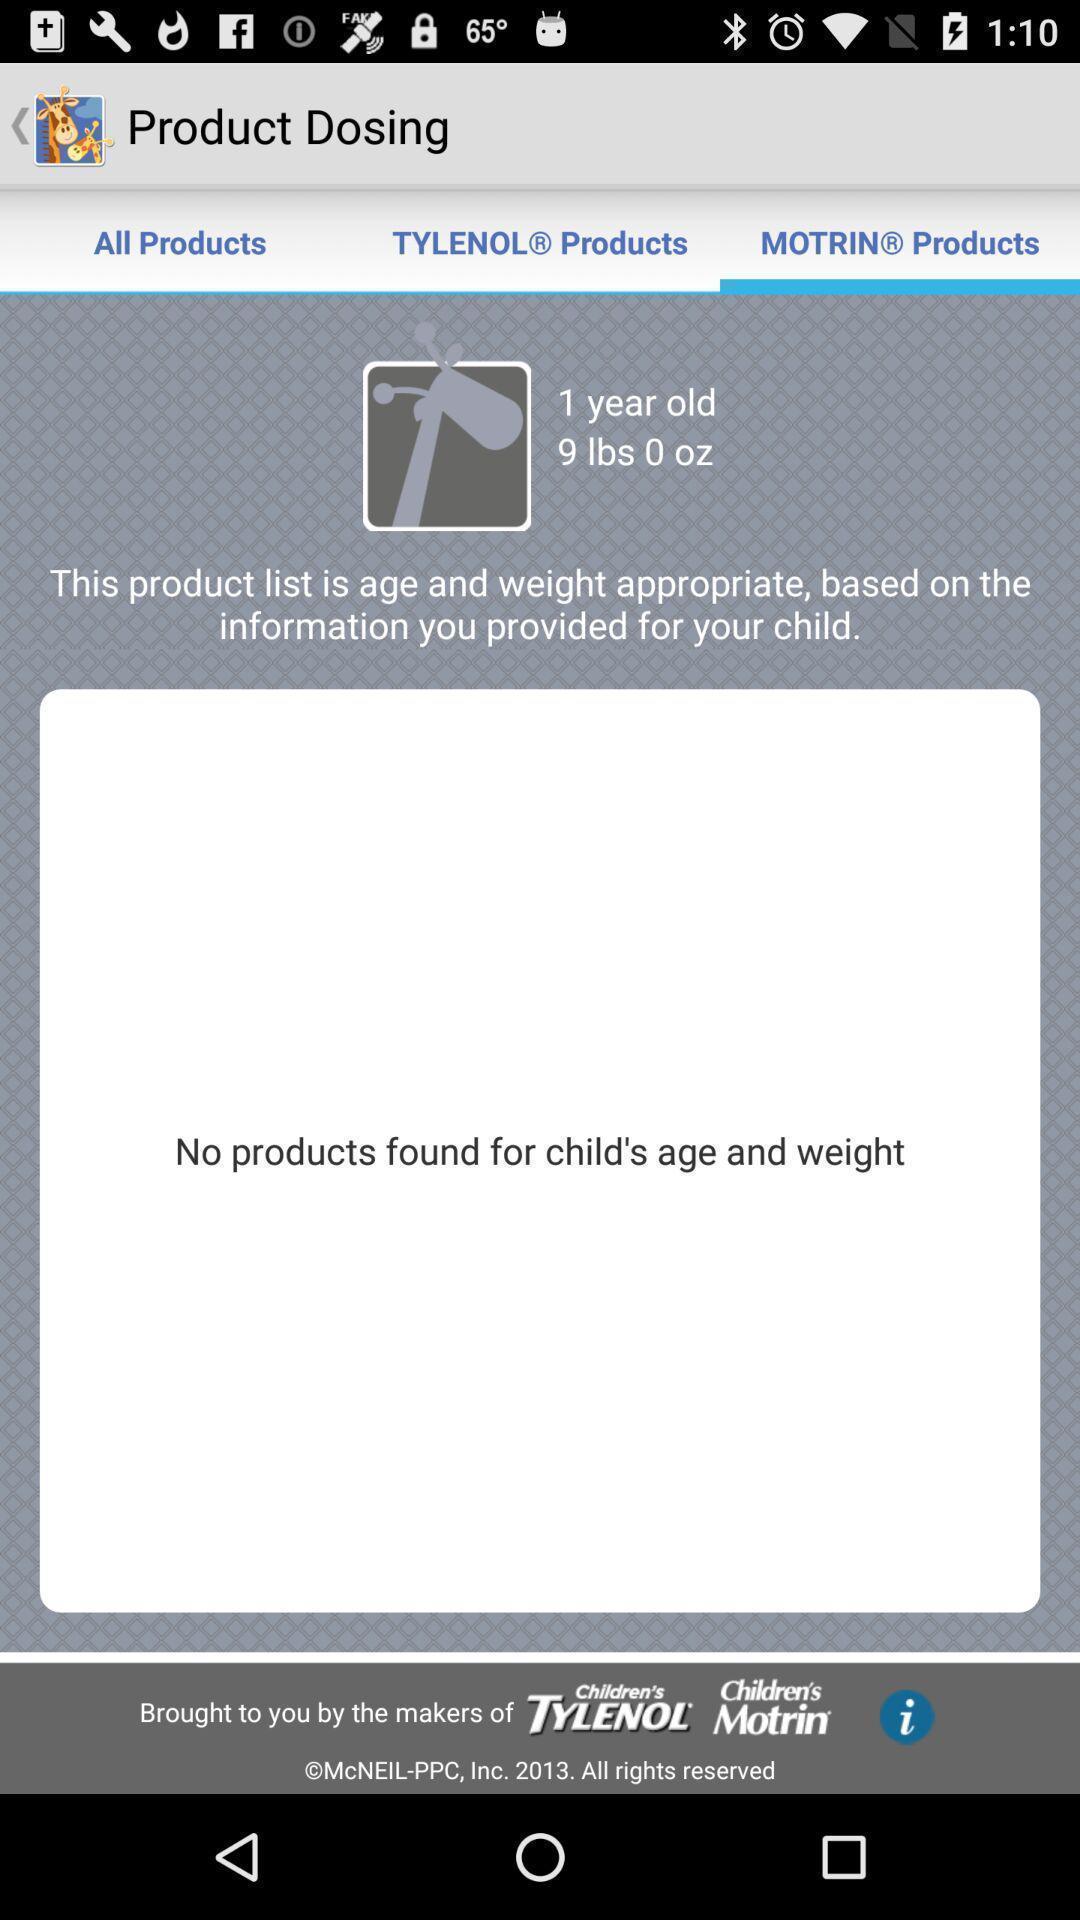Tell me about the visual elements in this screen capture. Pop-up showing message. 